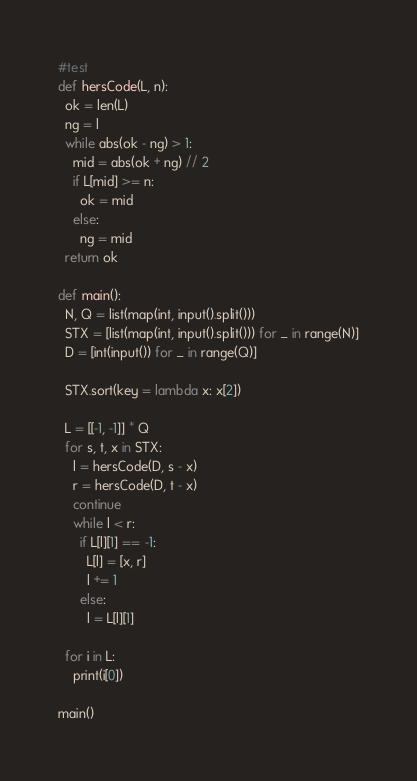Convert code to text. <code><loc_0><loc_0><loc_500><loc_500><_Python_>#test
def hersCode(L, n):
  ok = len(L)
  ng = l
  while abs(ok - ng) > 1:
    mid = abs(ok + ng) // 2
    if L[mid] >= n:
      ok = mid
    else:
      ng = mid
  return ok

def main():
  N, Q = list(map(int, input().split()))
  STX = [list(map(int, input().split())) for _ in range(N)]
  D = [int(input()) for _ in range(Q)]

  STX.sort(key = lambda x: x[2])

  L = [[-1, -1]] * Q
  for s, t, x in STX:
    l = hersCode(D, s - x)
    r = hersCode(D, t - x)
    continue
    while l < r:
      if L[l][1] == -1:
        L[l] = [x, r]
        l += 1
      else:
        l = L[l][1]

  for i in L:
    print(i[0])

main()
</code> 